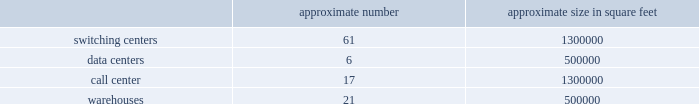In particular , we have received commitments for $ 30.0 billion in debt financing to fund the transactions which is comprised of ( i ) a $ 4.0 billion secured revolving credit facility , ( ii ) a $ 7.0 billion term loan credit facility and ( iii ) a $ 19.0 billion secured bridge loan facility .
Our reliance on the financing from the $ 19.0 billion secured bridge loan facility commitment is intended to be reduced through one or more secured note offerings or other long-term financings prior to the merger closing .
However , there can be no assurance that we will be able to issue any such secured notes or other long-term financings on terms we find acceptable or at all , especially in light of the recent debt market volatility , in which case we may have to exercise some or all of the commitments under the secured bridge facility to fund the transactions .
Accordingly , the costs of financing for the transactions may be higher than expected .
Credit rating downgrades could adversely affect the businesses , cash flows , financial condition and operating results of t-mobile and , following the transactions , the combined company .
Credit ratings impact the cost and availability of future borrowings , and , as a result , cost of capital .
Our current ratings reflect each rating agency 2019s opinion of our financial strength , operating performance and ability to meet our debt obligations or , following the completion of the transactions , obligations to the combined company 2019s obligors .
Each rating agency reviews these ratings periodically and there can be no assurance that such ratings will be maintained in the future .
A downgrade in the rating of us and/or sprint could adversely affect the businesses , cash flows , financial condition and operating results of t- mobile and , following the transactions , the combined company .
We have incurred , and will incur , direct and indirect costs as a result of the transactions .
We have incurred , and will incur , substantial expenses in connection with and as a result of completing the transactions , and over a period of time following the completion of the transactions , the combined company also expects to incur substantial expenses in connection with integrating and coordinating our and sprint 2019s businesses , operations , policies and procedures .
A portion of the transaction costs related to the transactions will be incurred regardless of whether the transactions are completed .
While we have assumed that a certain level of transaction expenses will be incurred , factors beyond our control could affect the total amount or the timing of these expenses .
Many of the expenses that will be incurred , by their nature , are difficult to estimate accurately .
These expenses will exceed the costs historically borne by us .
These costs could adversely affect our financial condition and results of operations prior to the transactions and the financial condition and results of operations of the combined company following the transactions .
Item 1b .
Unresolved staff comments item 2 .
Properties as of december 31 , 2018 , our significant properties that we primarily lease and use in connection with switching centers , data centers , call centers and warehouses were as follows: .
As of december 31 , 2018 , we primarily leased : 2022 approximately 64000 macro towers and 21000 distributed antenna system and small cell sites .
2022 approximately 2200 t-mobile and metro by t-mobile retail locations , including stores and kiosks ranging in size from approximately 100 square feet to 17000 square feet .
2022 office space totaling approximately 1000000 square feet for our corporate headquarters in bellevue , washington .
In january 2019 , we executed leases totaling approximately 170000 additional square feet for our corporate headquarters .
We use these offices for engineering and administrative purposes .
2022 office space throughout the u.s. , totaling approximately 1700000 square feet , for use by our regional offices primarily for administrative , engineering and sales purposes. .
What is the ratio of the warehouse space to the switching centers in square feet? 
Rationale: for every square foot of warehouse leased there was 2.6 square feet of switching space leased .
Computations: (1300000 / 500000)
Answer: 2.6. 